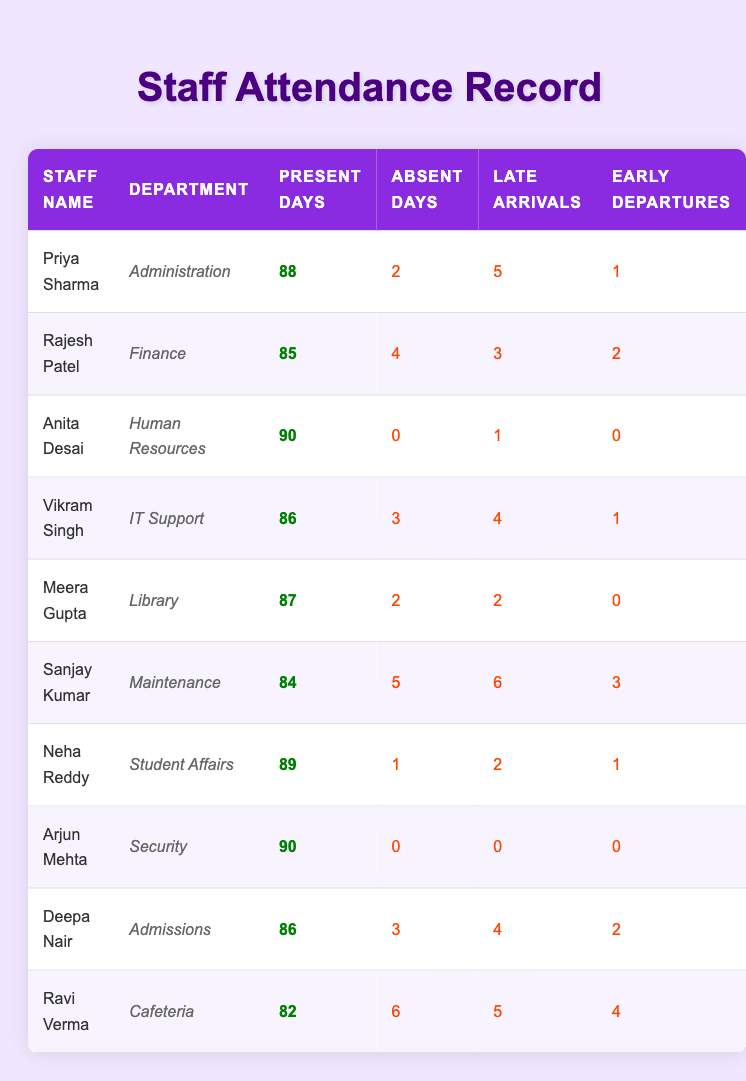What was the attendance record of Anita Desai? Anita Desai was present for 90 days, absent for 0 days, had 1 late arrival, and no early departures. You can find this data in the row corresponding to her name.
Answer: Present: 90, Absent: 0, Late: 1, Early: 0 Which staff member had the most absent days? By looking at the "Absent Days" column, we can see that Ravi Verma had the highest number of absent days, which is 6. This is more than any of the other staff members.
Answer: Ravi Verma How many present days did Rajesh Patel and Deepa Nair have combined? Rajesh Patel had 85 present days and Deepa Nair had 86. To find the combined present days, we add these two numbers: 85 + 86 = 171.
Answer: 171 Is it true that Neha Reddy had more late arrivals than Vikram Singh? Neha Reddy had 2 late arrivals while Vikram Singh had 4 late arrivals. Since 2 is less than 4, the statement is false.
Answer: No What is the average number of absent days for all staff members? To find the average, we need to sum the absent days of all staff members: 2 + 4 + 0 + 3 + 2 + 5 + 1 + 0 + 3 + 6 = 26. There are 10 staff members, so we divide the total by 10: 26 / 10 = 2.6.
Answer: 2.6 Which department had the highest presence based on present days? We can compare the present days across all departments. Anita Desai (HR) and Arjun Mehta (Security) both had 90 present days, which are the highest values. Thus, both of these departments had the highest presence.
Answer: Human Resources and Security How many staff members had exactly 2 early departures? By checking the "Early Departures" column, we find that Meera Gupta and Neha Reddy both had 2 early departures. Thus, there are two staff members with exactly 2 early departures.
Answer: 2 Who had the least present days and how many were they? Looking through the "Present Days" column, Ravi Verma had the least present days, with a total of 82 days.
Answer: Ravi Verma with 82 days What is the difference in present days between the staff with the highest and the lowest attendance? The staff with the highest attendance is Anita Desai with 90 present days, and the lowest is Ravi Verma with 82 present days. The difference is calculated as 90 - 82 = 8.
Answer: 8 